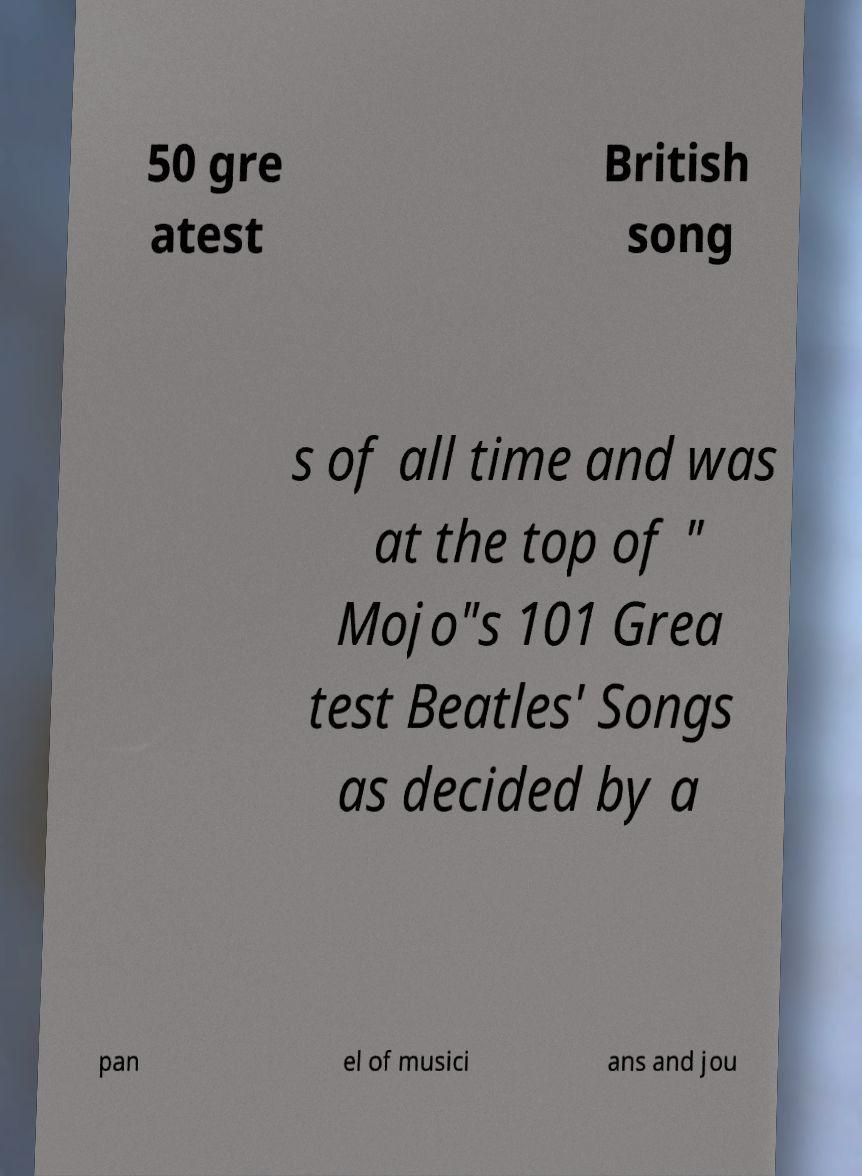Please identify and transcribe the text found in this image. 50 gre atest British song s of all time and was at the top of " Mojo"s 101 Grea test Beatles' Songs as decided by a pan el of musici ans and jou 